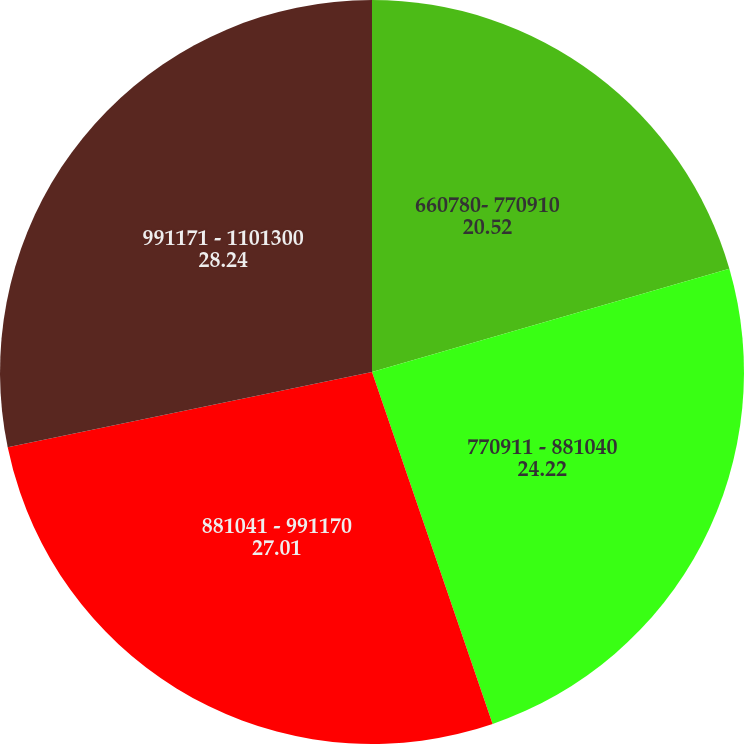Convert chart to OTSL. <chart><loc_0><loc_0><loc_500><loc_500><pie_chart><fcel>660780- 770910<fcel>770911 - 881040<fcel>881041 - 991170<fcel>991171 - 1101300<nl><fcel>20.52%<fcel>24.22%<fcel>27.01%<fcel>28.24%<nl></chart> 